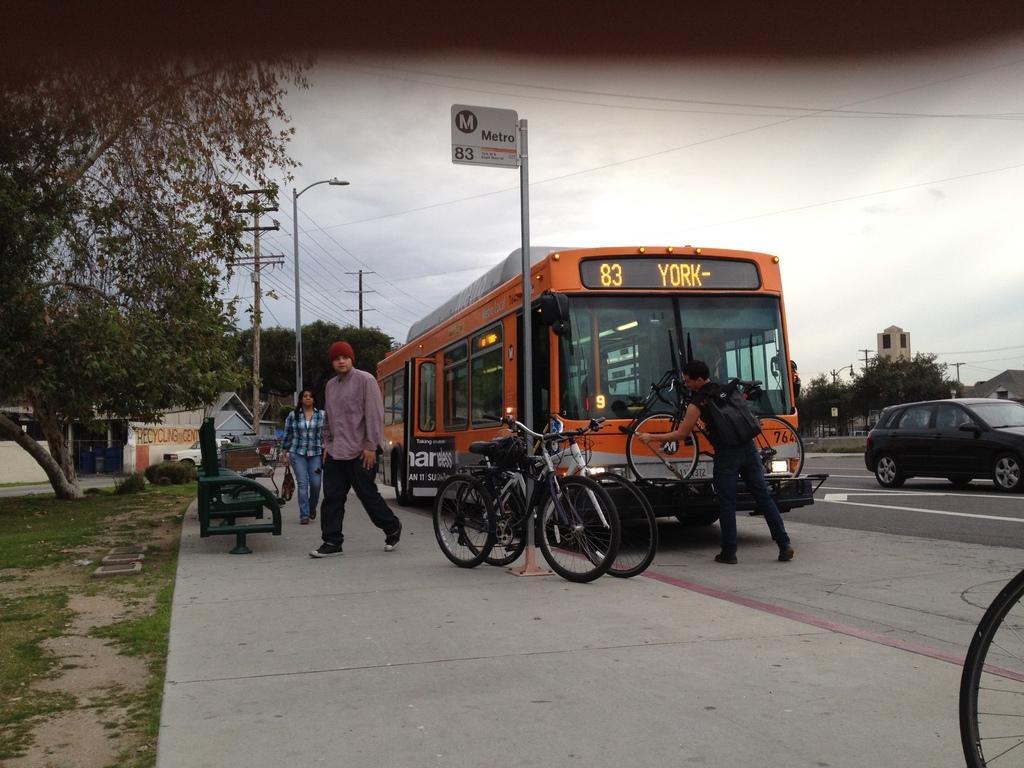In one or two sentences, can you explain what this image depicts? In the image we can see there are people walking, they are wearing clothes, shoes and they are carrying bags. We can even see there are vehicles on the road. Here we can see poles, board and text on the board. Here we can see electric poles, electric wires, trees and the sky. Here we can see benches, grass and the buildings. 